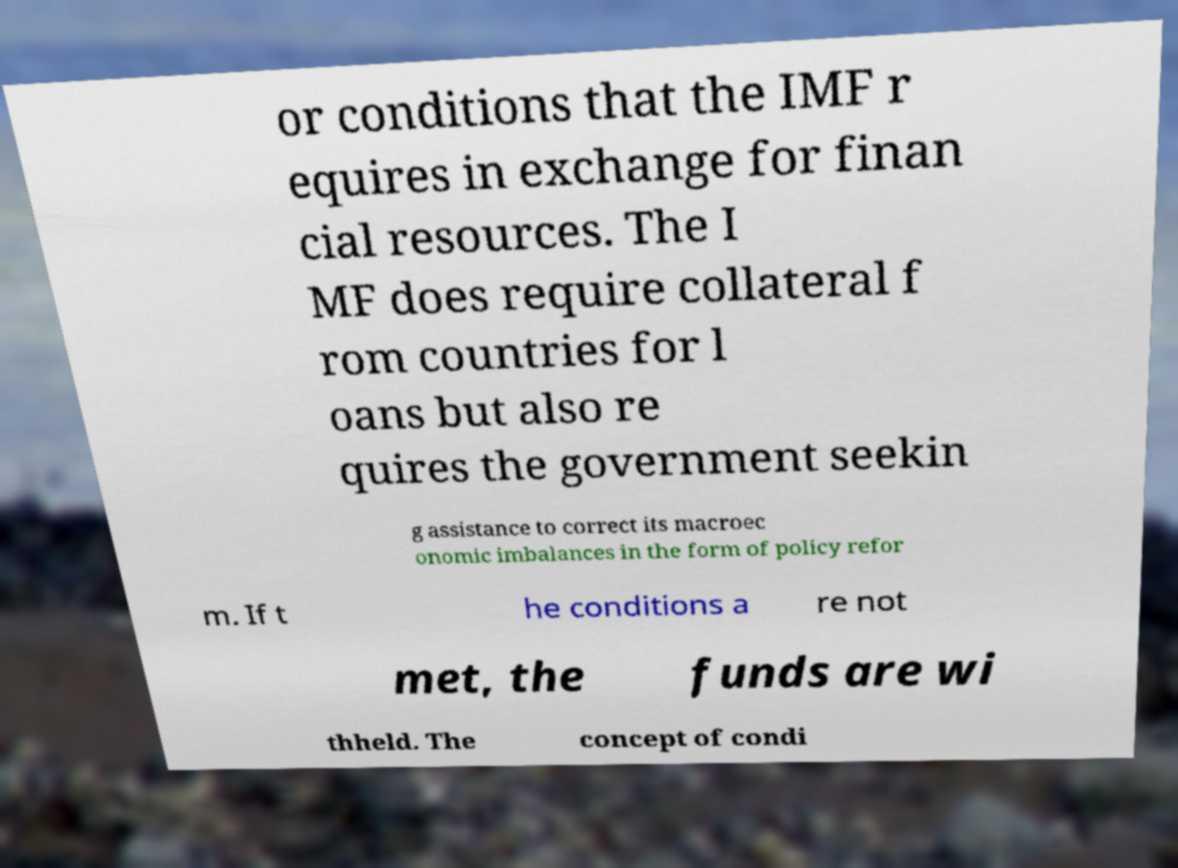Please read and relay the text visible in this image. What does it say? or conditions that the IMF r equires in exchange for finan cial resources. The I MF does require collateral f rom countries for l oans but also re quires the government seekin g assistance to correct its macroec onomic imbalances in the form of policy refor m. If t he conditions a re not met, the funds are wi thheld. The concept of condi 